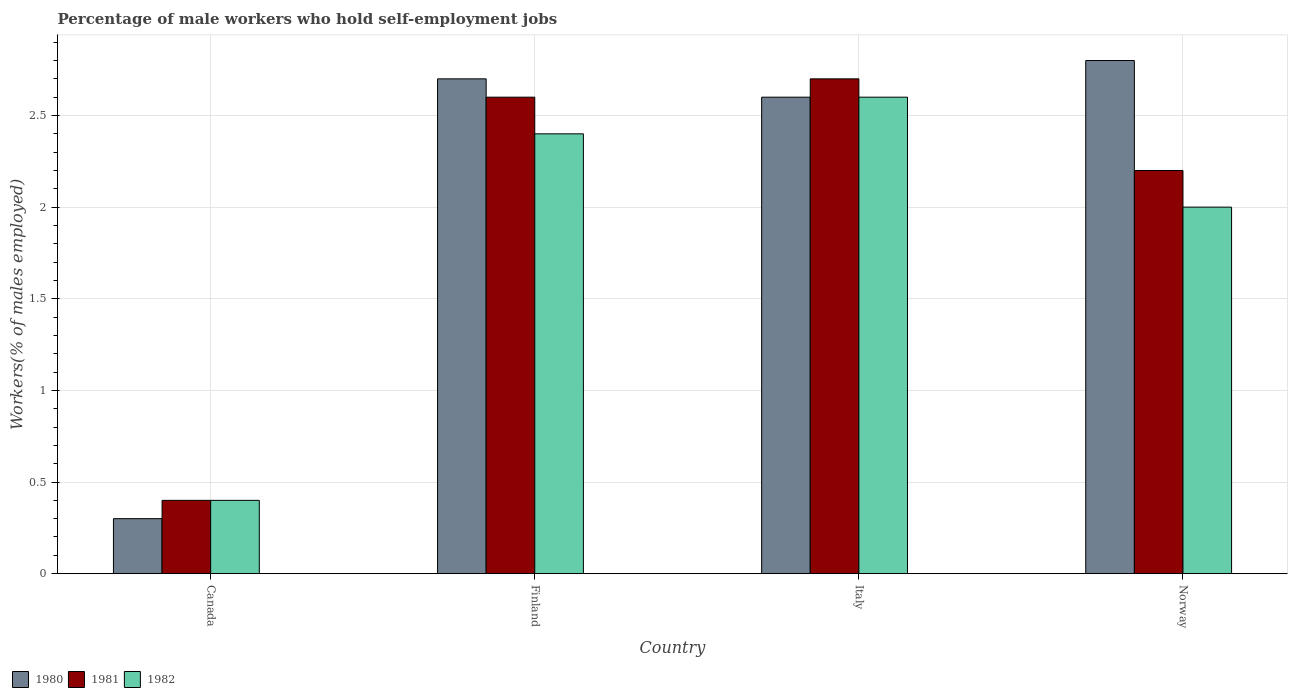How many different coloured bars are there?
Provide a succinct answer. 3. How many groups of bars are there?
Ensure brevity in your answer.  4. How many bars are there on the 3rd tick from the left?
Ensure brevity in your answer.  3. What is the label of the 1st group of bars from the left?
Offer a terse response. Canada. In how many cases, is the number of bars for a given country not equal to the number of legend labels?
Provide a succinct answer. 0. What is the percentage of self-employed male workers in 1982 in Italy?
Give a very brief answer. 2.6. Across all countries, what is the maximum percentage of self-employed male workers in 1980?
Ensure brevity in your answer.  2.8. Across all countries, what is the minimum percentage of self-employed male workers in 1982?
Offer a very short reply. 0.4. In which country was the percentage of self-employed male workers in 1981 minimum?
Your answer should be compact. Canada. What is the total percentage of self-employed male workers in 1982 in the graph?
Your response must be concise. 7.4. What is the difference between the percentage of self-employed male workers in 1980 in Canada and that in Italy?
Provide a succinct answer. -2.3. What is the difference between the percentage of self-employed male workers in 1982 in Italy and the percentage of self-employed male workers in 1980 in Finland?
Offer a very short reply. -0.1. What is the average percentage of self-employed male workers in 1981 per country?
Make the answer very short. 1.98. In how many countries, is the percentage of self-employed male workers in 1980 greater than 2.1 %?
Provide a succinct answer. 3. What is the ratio of the percentage of self-employed male workers in 1980 in Italy to that in Norway?
Offer a terse response. 0.93. Is the difference between the percentage of self-employed male workers in 1982 in Finland and Italy greater than the difference between the percentage of self-employed male workers in 1981 in Finland and Italy?
Keep it short and to the point. No. What is the difference between the highest and the second highest percentage of self-employed male workers in 1982?
Make the answer very short. -0.6. What is the difference between the highest and the lowest percentage of self-employed male workers in 1980?
Offer a very short reply. 2.5. In how many countries, is the percentage of self-employed male workers in 1982 greater than the average percentage of self-employed male workers in 1982 taken over all countries?
Offer a very short reply. 3. What does the 3rd bar from the right in Norway represents?
Provide a short and direct response. 1980. Is it the case that in every country, the sum of the percentage of self-employed male workers in 1982 and percentage of self-employed male workers in 1980 is greater than the percentage of self-employed male workers in 1981?
Give a very brief answer. Yes. Are all the bars in the graph horizontal?
Your response must be concise. No. What is the difference between two consecutive major ticks on the Y-axis?
Your response must be concise. 0.5. Does the graph contain grids?
Make the answer very short. Yes. Where does the legend appear in the graph?
Your answer should be very brief. Bottom left. How many legend labels are there?
Keep it short and to the point. 3. How are the legend labels stacked?
Make the answer very short. Horizontal. What is the title of the graph?
Make the answer very short. Percentage of male workers who hold self-employment jobs. Does "1965" appear as one of the legend labels in the graph?
Provide a succinct answer. No. What is the label or title of the Y-axis?
Keep it short and to the point. Workers(% of males employed). What is the Workers(% of males employed) of 1980 in Canada?
Make the answer very short. 0.3. What is the Workers(% of males employed) of 1981 in Canada?
Make the answer very short. 0.4. What is the Workers(% of males employed) in 1982 in Canada?
Offer a very short reply. 0.4. What is the Workers(% of males employed) in 1980 in Finland?
Your answer should be compact. 2.7. What is the Workers(% of males employed) in 1981 in Finland?
Offer a terse response. 2.6. What is the Workers(% of males employed) of 1982 in Finland?
Provide a short and direct response. 2.4. What is the Workers(% of males employed) in 1980 in Italy?
Provide a short and direct response. 2.6. What is the Workers(% of males employed) in 1981 in Italy?
Keep it short and to the point. 2.7. What is the Workers(% of males employed) of 1982 in Italy?
Provide a succinct answer. 2.6. What is the Workers(% of males employed) of 1980 in Norway?
Offer a terse response. 2.8. What is the Workers(% of males employed) in 1981 in Norway?
Ensure brevity in your answer.  2.2. What is the Workers(% of males employed) in 1982 in Norway?
Your response must be concise. 2. Across all countries, what is the maximum Workers(% of males employed) in 1980?
Your response must be concise. 2.8. Across all countries, what is the maximum Workers(% of males employed) in 1981?
Offer a terse response. 2.7. Across all countries, what is the maximum Workers(% of males employed) in 1982?
Your answer should be very brief. 2.6. Across all countries, what is the minimum Workers(% of males employed) of 1980?
Keep it short and to the point. 0.3. Across all countries, what is the minimum Workers(% of males employed) in 1981?
Your response must be concise. 0.4. Across all countries, what is the minimum Workers(% of males employed) of 1982?
Give a very brief answer. 0.4. What is the difference between the Workers(% of males employed) in 1980 in Canada and that in Finland?
Make the answer very short. -2.4. What is the difference between the Workers(% of males employed) of 1981 in Canada and that in Finland?
Your answer should be compact. -2.2. What is the difference between the Workers(% of males employed) of 1982 in Canada and that in Finland?
Your answer should be compact. -2. What is the difference between the Workers(% of males employed) in 1980 in Canada and that in Italy?
Offer a terse response. -2.3. What is the difference between the Workers(% of males employed) in 1981 in Canada and that in Italy?
Offer a very short reply. -2.3. What is the difference between the Workers(% of males employed) of 1982 in Canada and that in Italy?
Offer a very short reply. -2.2. What is the difference between the Workers(% of males employed) in 1981 in Canada and that in Norway?
Your answer should be very brief. -1.8. What is the difference between the Workers(% of males employed) in 1982 in Canada and that in Norway?
Your response must be concise. -1.6. What is the difference between the Workers(% of males employed) of 1980 in Finland and that in Italy?
Ensure brevity in your answer.  0.1. What is the difference between the Workers(% of males employed) of 1980 in Finland and that in Norway?
Keep it short and to the point. -0.1. What is the difference between the Workers(% of males employed) of 1981 in Finland and that in Norway?
Provide a short and direct response. 0.4. What is the difference between the Workers(% of males employed) in 1980 in Italy and that in Norway?
Give a very brief answer. -0.2. What is the difference between the Workers(% of males employed) of 1981 in Italy and that in Norway?
Provide a succinct answer. 0.5. What is the difference between the Workers(% of males employed) of 1980 in Canada and the Workers(% of males employed) of 1982 in Italy?
Provide a short and direct response. -2.3. What is the difference between the Workers(% of males employed) in 1981 in Canada and the Workers(% of males employed) in 1982 in Italy?
Offer a very short reply. -2.2. What is the difference between the Workers(% of males employed) of 1980 in Canada and the Workers(% of males employed) of 1981 in Norway?
Provide a succinct answer. -1.9. What is the difference between the Workers(% of males employed) of 1981 in Finland and the Workers(% of males employed) of 1982 in Italy?
Offer a very short reply. 0. What is the difference between the Workers(% of males employed) of 1980 in Finland and the Workers(% of males employed) of 1982 in Norway?
Make the answer very short. 0.7. What is the difference between the Workers(% of males employed) of 1981 in Finland and the Workers(% of males employed) of 1982 in Norway?
Give a very brief answer. 0.6. What is the difference between the Workers(% of males employed) in 1980 in Italy and the Workers(% of males employed) in 1982 in Norway?
Provide a succinct answer. 0.6. What is the average Workers(% of males employed) of 1981 per country?
Provide a succinct answer. 1.98. What is the average Workers(% of males employed) of 1982 per country?
Make the answer very short. 1.85. What is the difference between the Workers(% of males employed) of 1980 and Workers(% of males employed) of 1981 in Canada?
Offer a terse response. -0.1. What is the difference between the Workers(% of males employed) in 1980 and Workers(% of males employed) in 1982 in Canada?
Give a very brief answer. -0.1. What is the difference between the Workers(% of males employed) in 1981 and Workers(% of males employed) in 1982 in Canada?
Keep it short and to the point. 0. What is the difference between the Workers(% of males employed) of 1980 and Workers(% of males employed) of 1981 in Finland?
Provide a short and direct response. 0.1. What is the difference between the Workers(% of males employed) in 1980 and Workers(% of males employed) in 1982 in Finland?
Your response must be concise. 0.3. What is the difference between the Workers(% of males employed) of 1980 and Workers(% of males employed) of 1982 in Italy?
Provide a short and direct response. 0. What is the difference between the Workers(% of males employed) in 1981 and Workers(% of males employed) in 1982 in Italy?
Provide a short and direct response. 0.1. What is the difference between the Workers(% of males employed) in 1980 and Workers(% of males employed) in 1982 in Norway?
Provide a short and direct response. 0.8. What is the ratio of the Workers(% of males employed) of 1981 in Canada to that in Finland?
Your answer should be very brief. 0.15. What is the ratio of the Workers(% of males employed) in 1980 in Canada to that in Italy?
Your answer should be very brief. 0.12. What is the ratio of the Workers(% of males employed) in 1981 in Canada to that in Italy?
Give a very brief answer. 0.15. What is the ratio of the Workers(% of males employed) in 1982 in Canada to that in Italy?
Your answer should be very brief. 0.15. What is the ratio of the Workers(% of males employed) of 1980 in Canada to that in Norway?
Keep it short and to the point. 0.11. What is the ratio of the Workers(% of males employed) in 1981 in Canada to that in Norway?
Ensure brevity in your answer.  0.18. What is the ratio of the Workers(% of males employed) in 1982 in Canada to that in Norway?
Make the answer very short. 0.2. What is the ratio of the Workers(% of males employed) in 1980 in Finland to that in Italy?
Keep it short and to the point. 1.04. What is the ratio of the Workers(% of males employed) of 1982 in Finland to that in Italy?
Give a very brief answer. 0.92. What is the ratio of the Workers(% of males employed) of 1981 in Finland to that in Norway?
Provide a short and direct response. 1.18. What is the ratio of the Workers(% of males employed) in 1981 in Italy to that in Norway?
Provide a succinct answer. 1.23. What is the ratio of the Workers(% of males employed) of 1982 in Italy to that in Norway?
Ensure brevity in your answer.  1.3. What is the difference between the highest and the second highest Workers(% of males employed) in 1980?
Keep it short and to the point. 0.1. What is the difference between the highest and the second highest Workers(% of males employed) in 1981?
Provide a short and direct response. 0.1. What is the difference between the highest and the second highest Workers(% of males employed) of 1982?
Keep it short and to the point. 0.2. What is the difference between the highest and the lowest Workers(% of males employed) of 1980?
Ensure brevity in your answer.  2.5. 